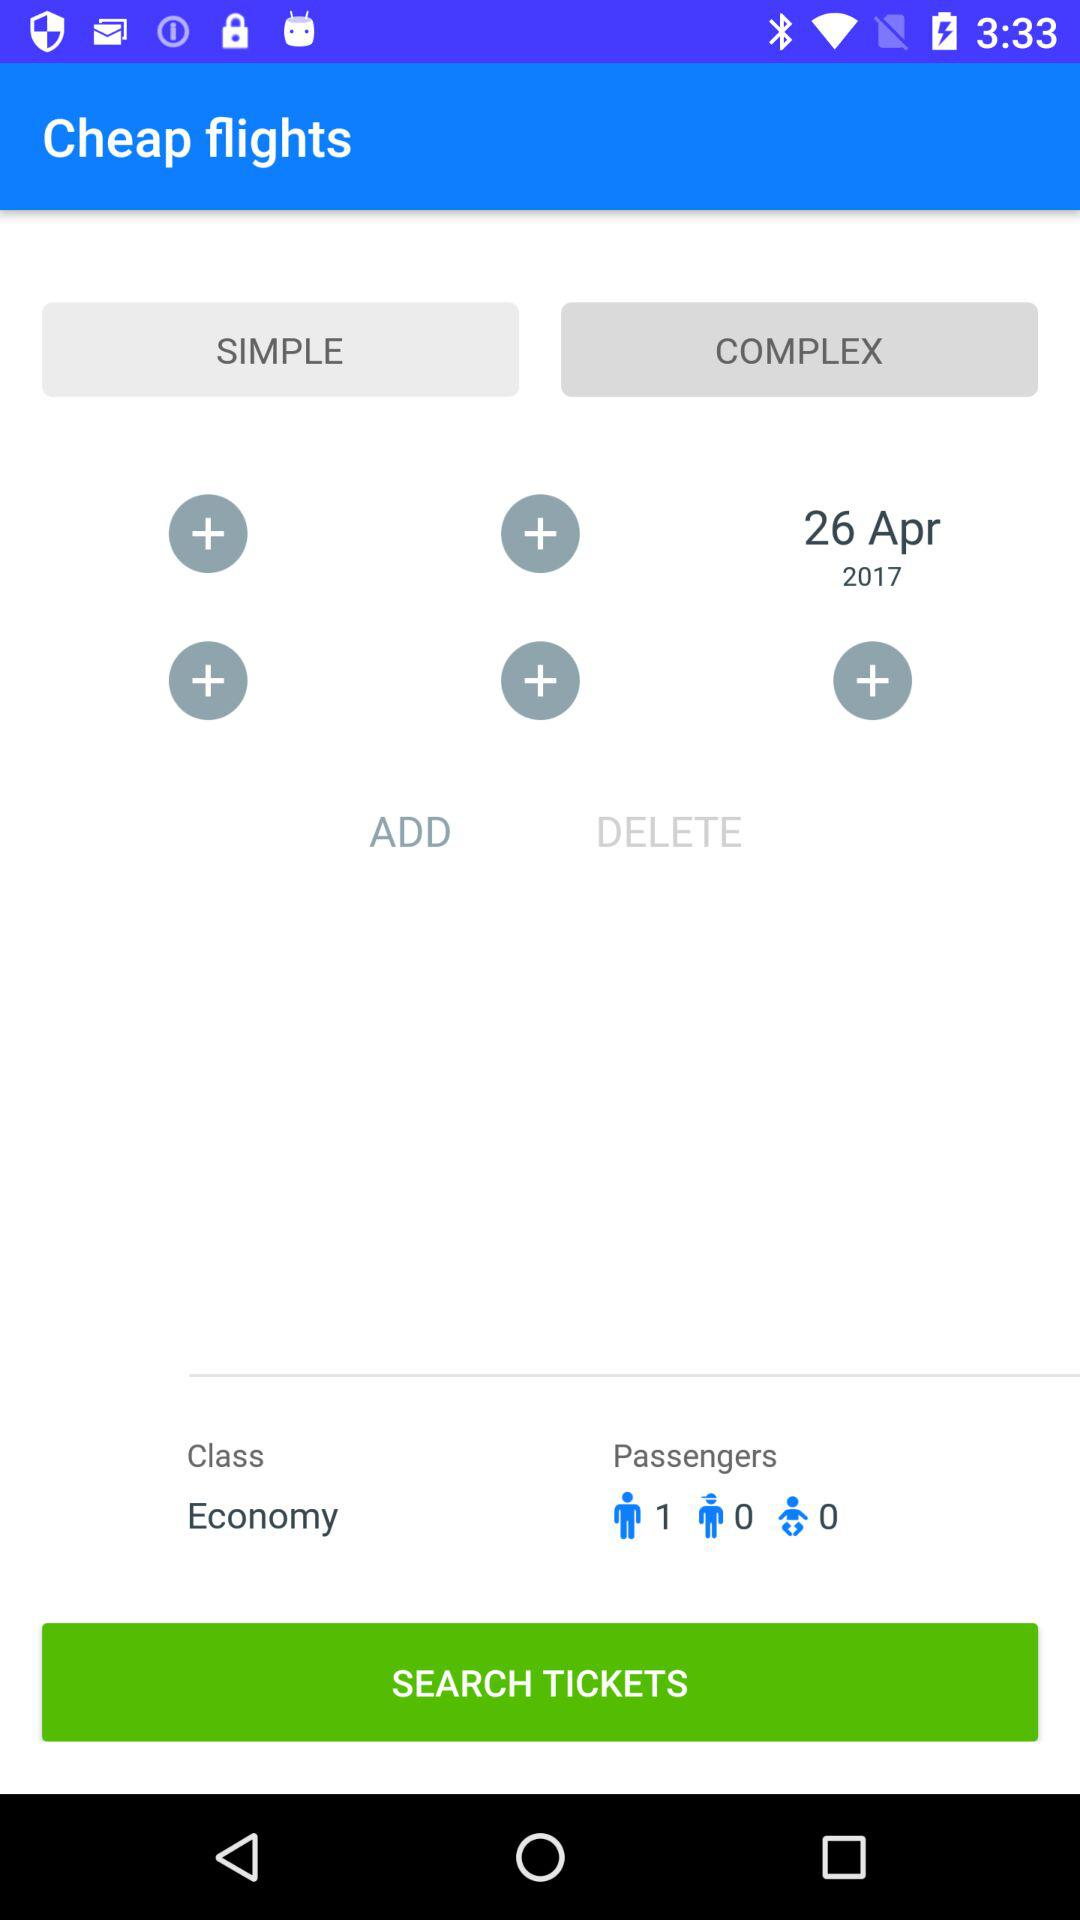How many people are flying?
Answer the question using a single word or phrase. 1 